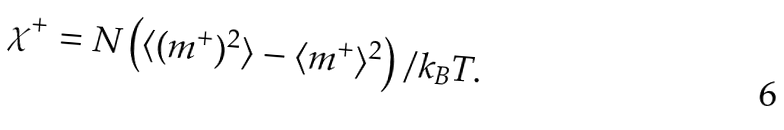Convert formula to latex. <formula><loc_0><loc_0><loc_500><loc_500>\chi ^ { + } = N \left ( \langle ( m ^ { + } ) ^ { 2 } \rangle - \langle m ^ { + } \rangle ^ { 2 } \right ) / k _ { B } T .</formula> 